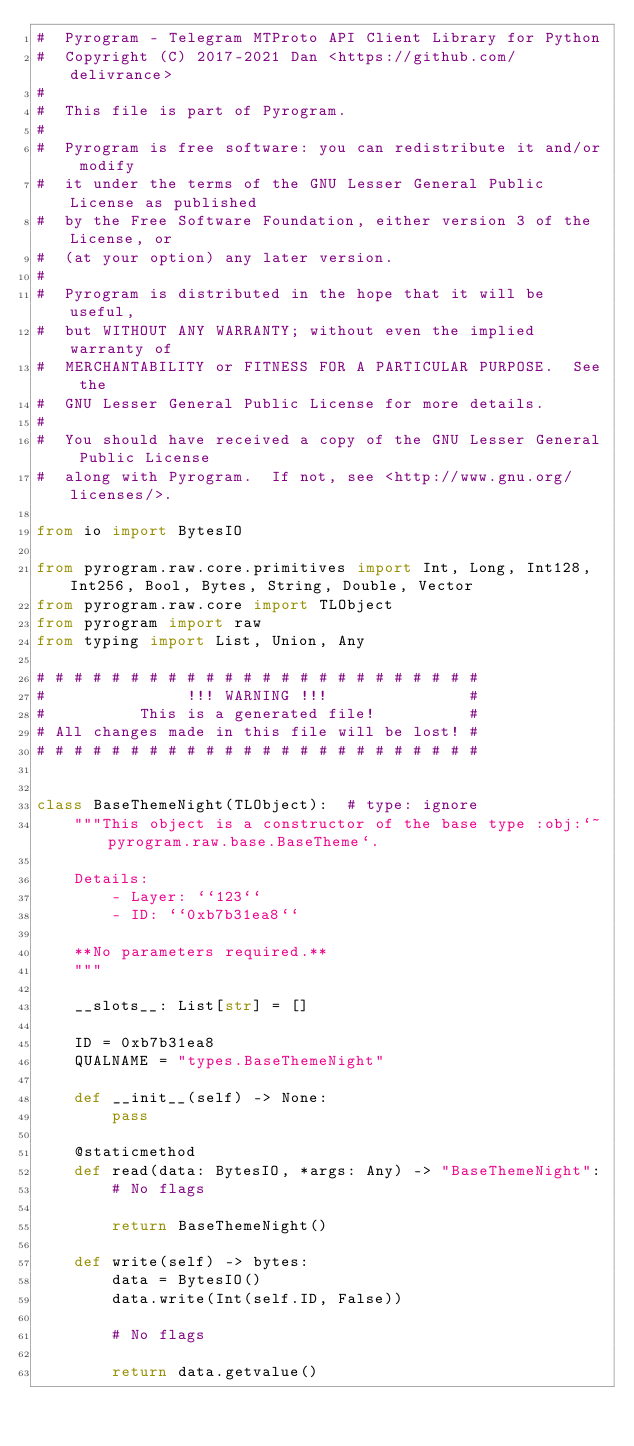Convert code to text. <code><loc_0><loc_0><loc_500><loc_500><_Python_>#  Pyrogram - Telegram MTProto API Client Library for Python
#  Copyright (C) 2017-2021 Dan <https://github.com/delivrance>
#
#  This file is part of Pyrogram.
#
#  Pyrogram is free software: you can redistribute it and/or modify
#  it under the terms of the GNU Lesser General Public License as published
#  by the Free Software Foundation, either version 3 of the License, or
#  (at your option) any later version.
#
#  Pyrogram is distributed in the hope that it will be useful,
#  but WITHOUT ANY WARRANTY; without even the implied warranty of
#  MERCHANTABILITY or FITNESS FOR A PARTICULAR PURPOSE.  See the
#  GNU Lesser General Public License for more details.
#
#  You should have received a copy of the GNU Lesser General Public License
#  along with Pyrogram.  If not, see <http://www.gnu.org/licenses/>.

from io import BytesIO

from pyrogram.raw.core.primitives import Int, Long, Int128, Int256, Bool, Bytes, String, Double, Vector
from pyrogram.raw.core import TLObject
from pyrogram import raw
from typing import List, Union, Any

# # # # # # # # # # # # # # # # # # # # # # # #
#               !!! WARNING !!!               #
#          This is a generated file!          #
# All changes made in this file will be lost! #
# # # # # # # # # # # # # # # # # # # # # # # #


class BaseThemeNight(TLObject):  # type: ignore
    """This object is a constructor of the base type :obj:`~pyrogram.raw.base.BaseTheme`.

    Details:
        - Layer: ``123``
        - ID: ``0xb7b31ea8``

    **No parameters required.**
    """

    __slots__: List[str] = []

    ID = 0xb7b31ea8
    QUALNAME = "types.BaseThemeNight"

    def __init__(self) -> None:
        pass

    @staticmethod
    def read(data: BytesIO, *args: Any) -> "BaseThemeNight":
        # No flags

        return BaseThemeNight()

    def write(self) -> bytes:
        data = BytesIO()
        data.write(Int(self.ID, False))

        # No flags

        return data.getvalue()
</code> 